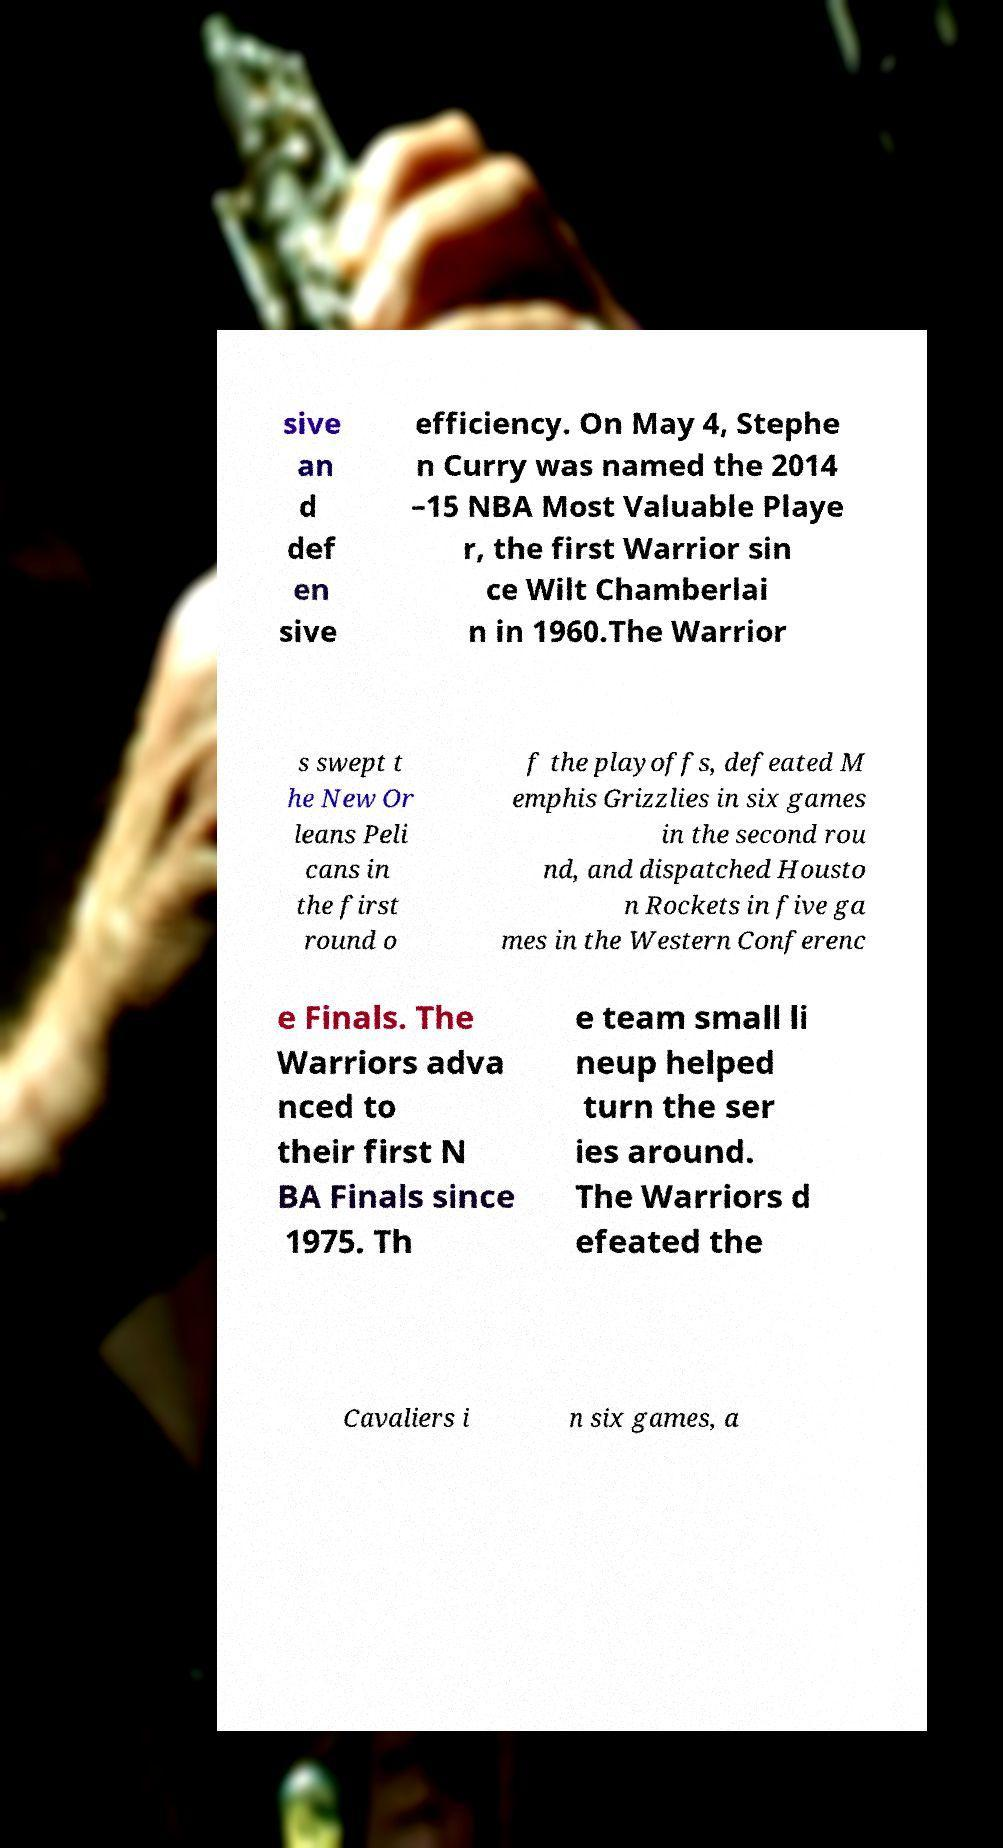Can you read and provide the text displayed in the image?This photo seems to have some interesting text. Can you extract and type it out for me? sive an d def en sive efficiency. On May 4, Stephe n Curry was named the 2014 –15 NBA Most Valuable Playe r, the first Warrior sin ce Wilt Chamberlai n in 1960.The Warrior s swept t he New Or leans Peli cans in the first round o f the playoffs, defeated M emphis Grizzlies in six games in the second rou nd, and dispatched Housto n Rockets in five ga mes in the Western Conferenc e Finals. The Warriors adva nced to their first N BA Finals since 1975. Th e team small li neup helped turn the ser ies around. The Warriors d efeated the Cavaliers i n six games, a 